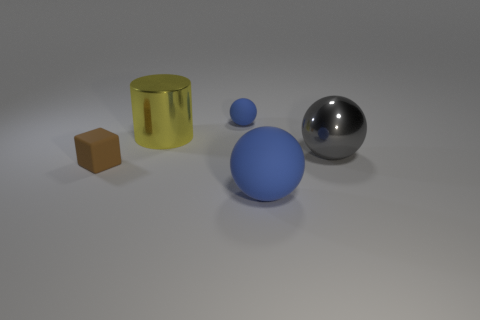Is the sphere that is to the left of the large blue object made of the same material as the sphere to the right of the big rubber object? While we cannot determine the materials with certainty from the image, it appears that the spheres have different textures: the sphere to the left of the large blue object has a matte finish, suggesting a non-reflective material, whereas the sphere to the right of the big yellow object – which seems to be rubber – is shiny, implying it might be made of a reflective material like plastic or metal. 